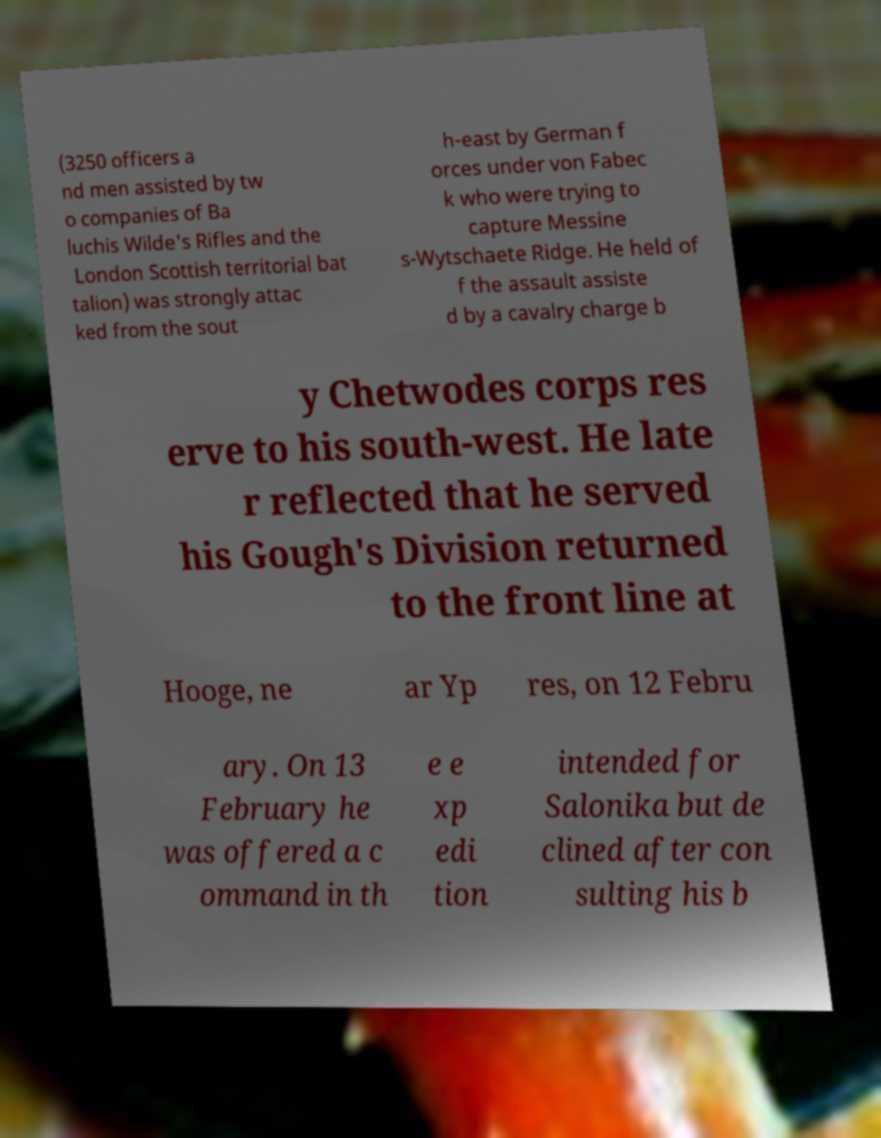Please identify and transcribe the text found in this image. (3250 officers a nd men assisted by tw o companies of Ba luchis Wilde's Rifles and the London Scottish territorial bat talion) was strongly attac ked from the sout h-east by German f orces under von Fabec k who were trying to capture Messine s-Wytschaete Ridge. He held of f the assault assiste d by a cavalry charge b y Chetwodes corps res erve to his south-west. He late r reflected that he served his Gough's Division returned to the front line at Hooge, ne ar Yp res, on 12 Febru ary. On 13 February he was offered a c ommand in th e e xp edi tion intended for Salonika but de clined after con sulting his b 